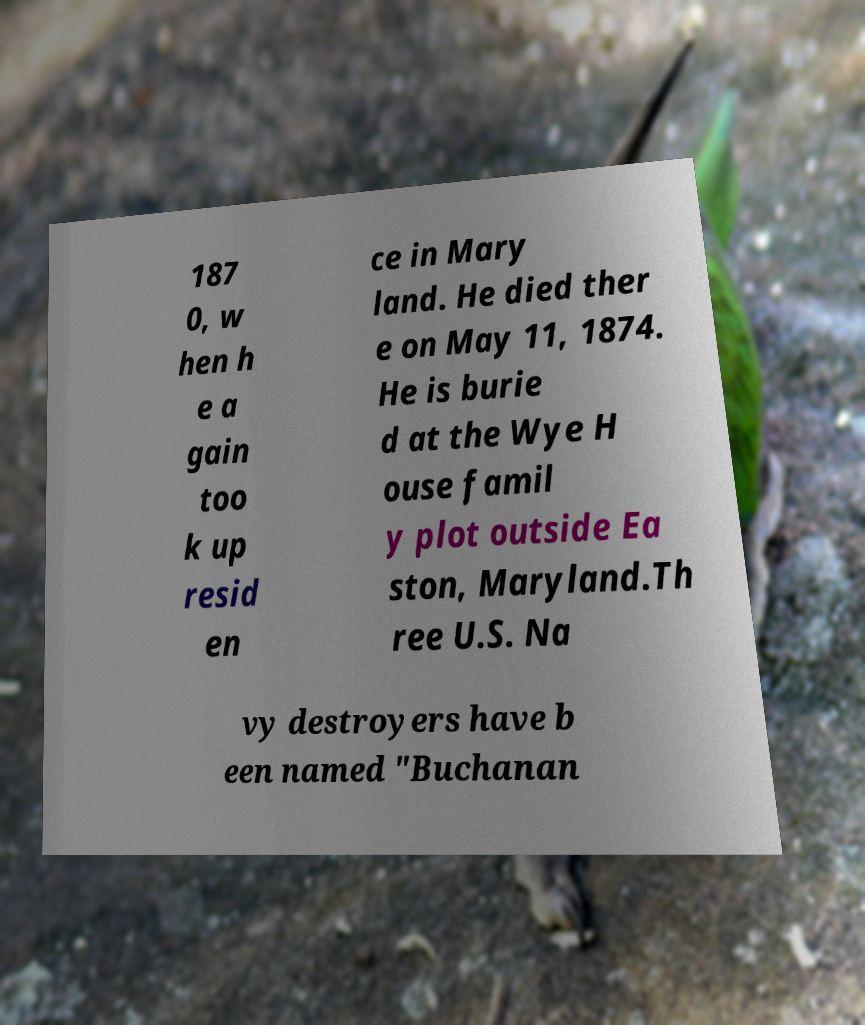Please read and relay the text visible in this image. What does it say? 187 0, w hen h e a gain too k up resid en ce in Mary land. He died ther e on May 11, 1874. He is burie d at the Wye H ouse famil y plot outside Ea ston, Maryland.Th ree U.S. Na vy destroyers have b een named "Buchanan 